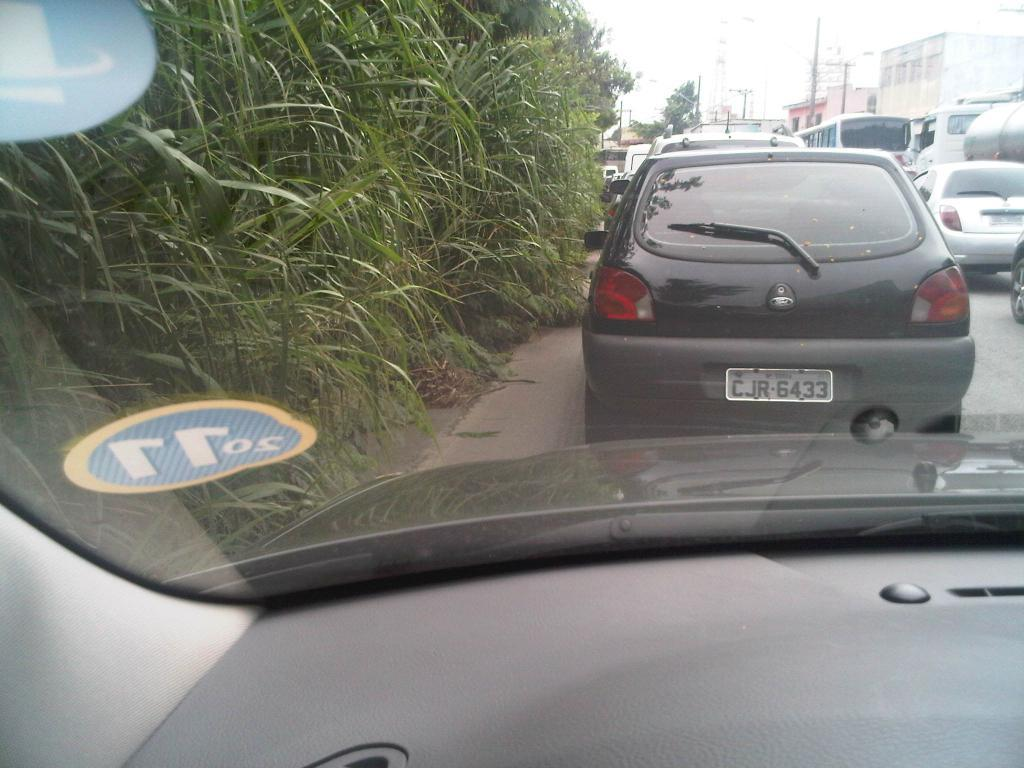<image>
Share a concise interpretation of the image provided. a dashboard camera screenshot dhows the car ahead licence plate numbered CJR6433 